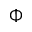Convert formula to latex. <formula><loc_0><loc_0><loc_500><loc_500>\Phi</formula> 